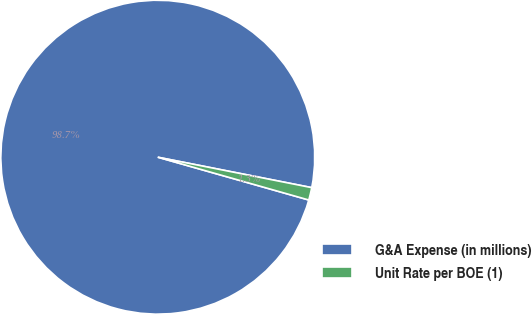<chart> <loc_0><loc_0><loc_500><loc_500><pie_chart><fcel>G&A Expense (in millions)<fcel>Unit Rate per BOE (1)<nl><fcel>98.71%<fcel>1.29%<nl></chart> 